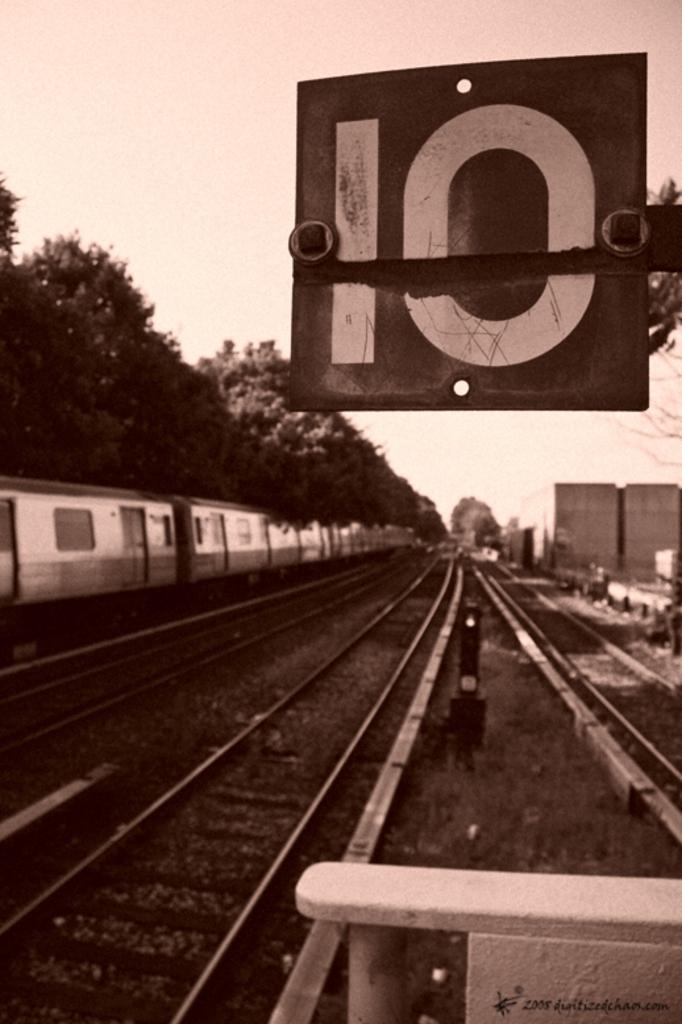What does the top sign say?
Provide a succinct answer. 10. 